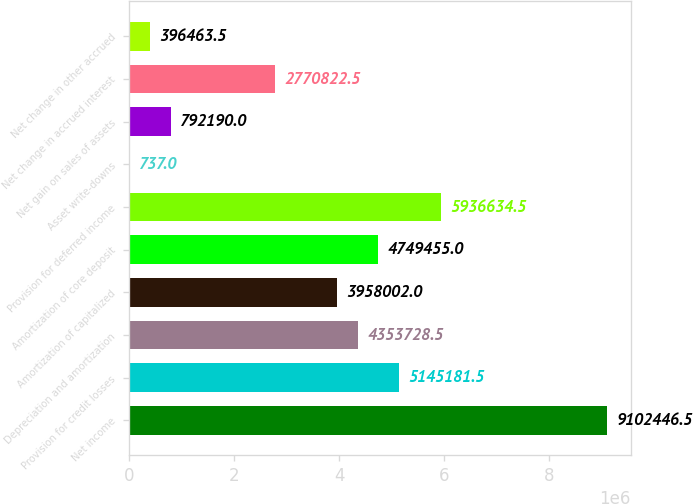Convert chart. <chart><loc_0><loc_0><loc_500><loc_500><bar_chart><fcel>Net income<fcel>Provision for credit losses<fcel>Depreciation and amortization<fcel>Amortization of capitalized<fcel>Amortization of core deposit<fcel>Provision for deferred income<fcel>Asset write-downs<fcel>Net gain on sales of assets<fcel>Net change in accrued interest<fcel>Net change in other accrued<nl><fcel>9.10245e+06<fcel>5.14518e+06<fcel>4.35373e+06<fcel>3.958e+06<fcel>4.74946e+06<fcel>5.93663e+06<fcel>737<fcel>792190<fcel>2.77082e+06<fcel>396464<nl></chart> 